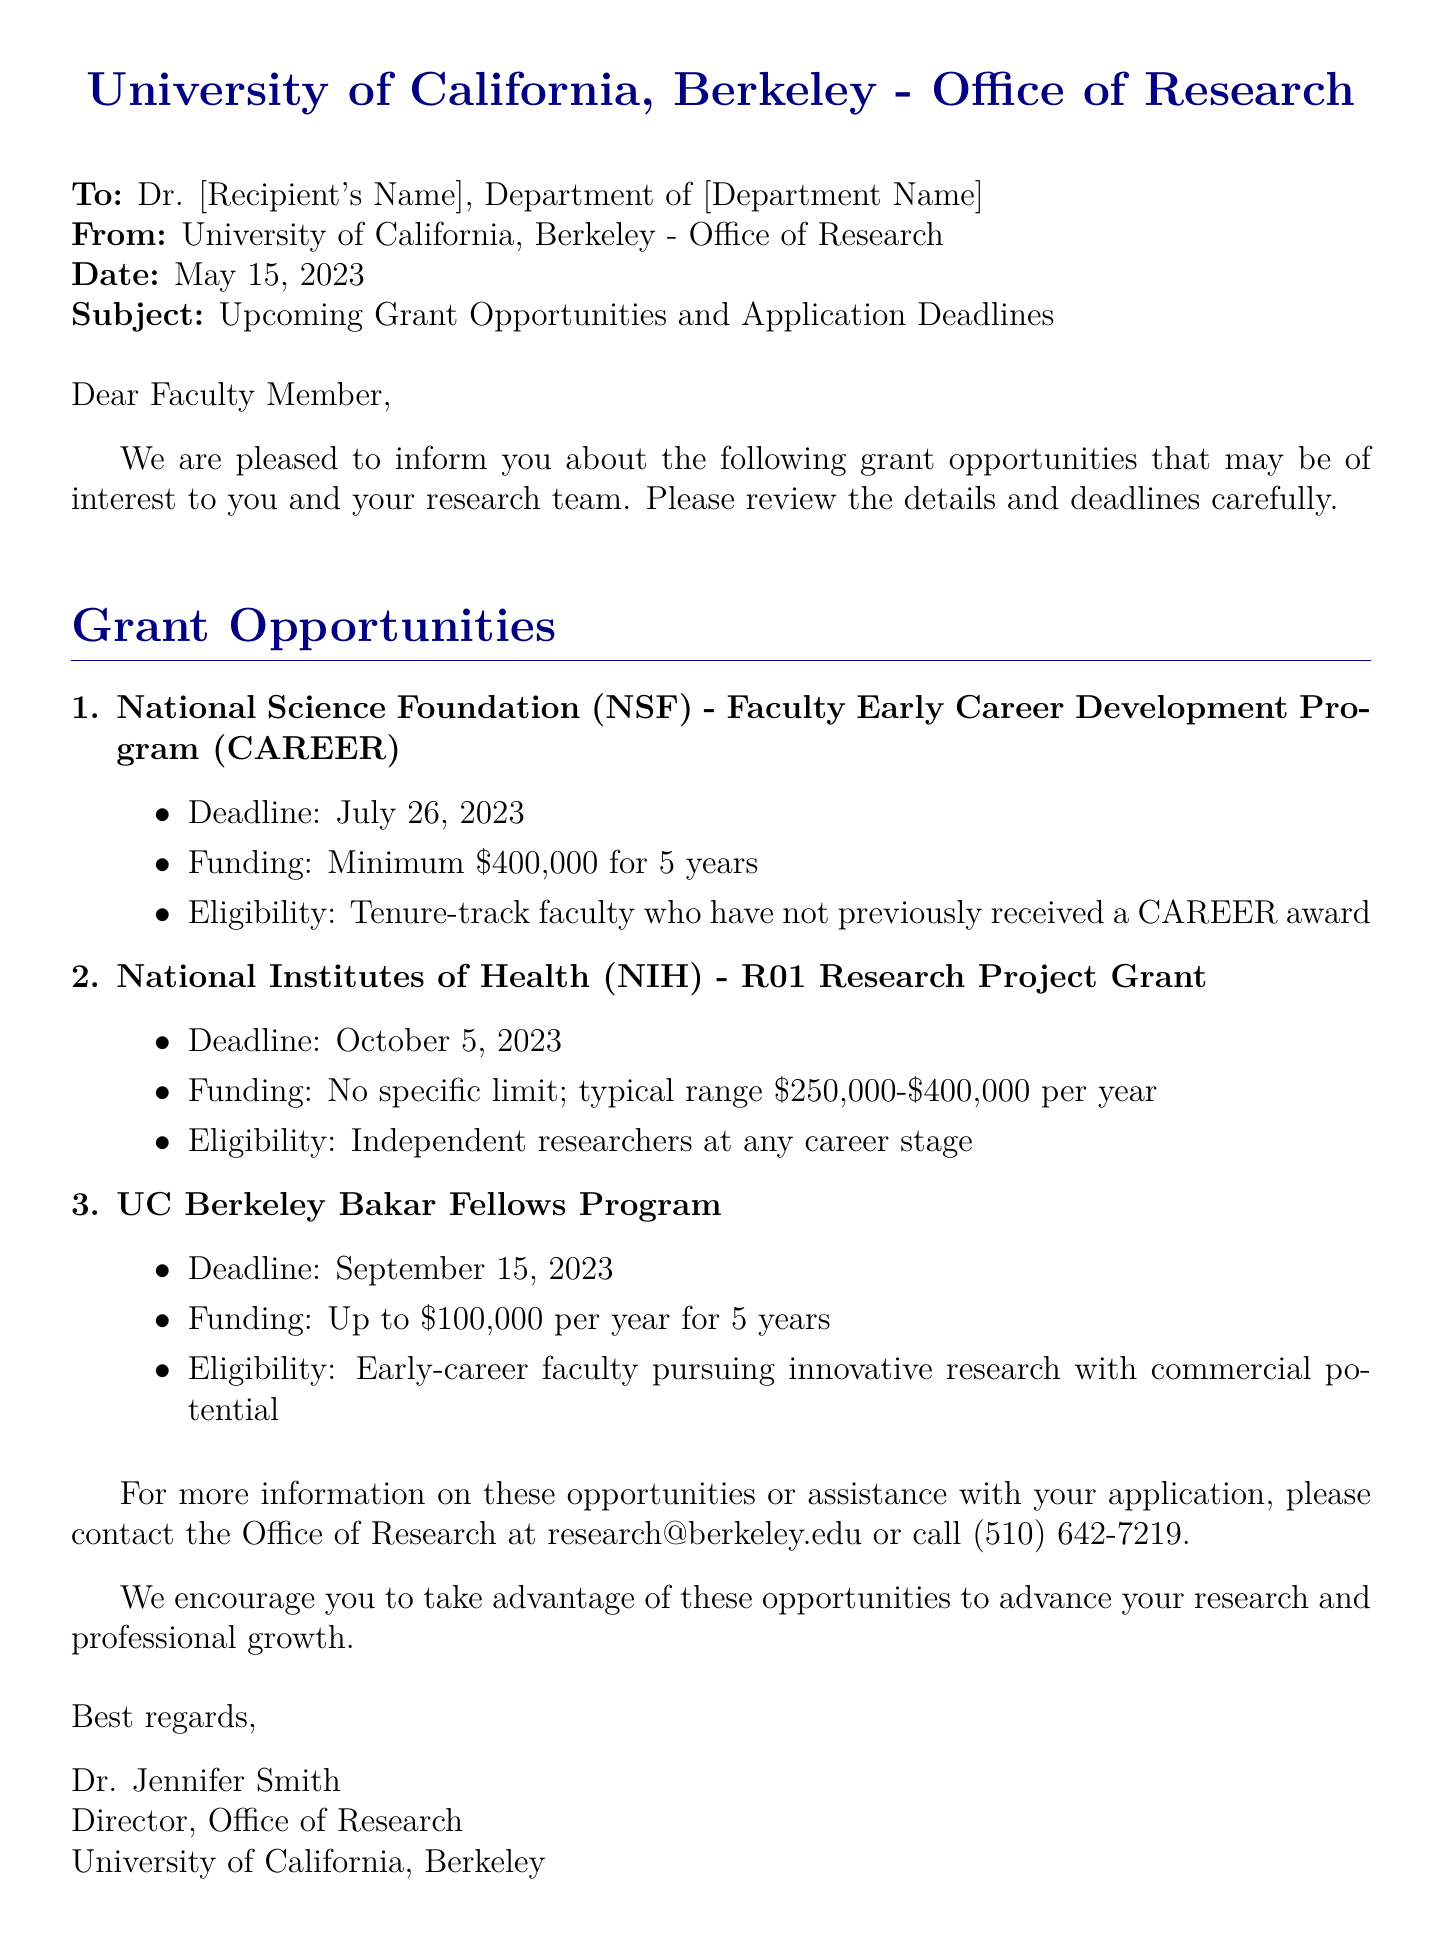What is the deadline for the NSF CAREER grant? The deadline for the NSF CAREER grant is mentioned in the document.
Answer: July 26, 2023 What is the maximum funding amount for the NIH R01 research grant? The document specifies the typical funding range for the NIH R01 research grant.
Answer: No specific limit Who is eligible for the UC Berkeley Bakar Fellows Program? The document states the eligibility criteria for the Bakar Fellows Program.
Answer: Early-career faculty pursuing innovative research What is the minimum funding for the NSF CAREER program? The minimum funding amount for the NSF CAREER program is clearly outlined in the document.
Answer: $400,000 How many years of funding does the UC Berkeley Bakar Fellows Program provide? The document indicates the duration of funding for this program.
Answer: 5 years What type of document is this? The nature of the document can be identified based on its header and subject.
Answer: Fax Who is the director of the Office of Research? The document states the name and position at the end.
Answer: Dr. Jennifer Smith What is the typical funding range for NIH R01 grants per year? This range is detailed in the NIH R01 grant section of the document.
Answer: $250,000-$400,000 per year What is the contact email for the Office of Research? The document provides contact details including the email for further inquiries.
Answer: research@berkeley.edu 